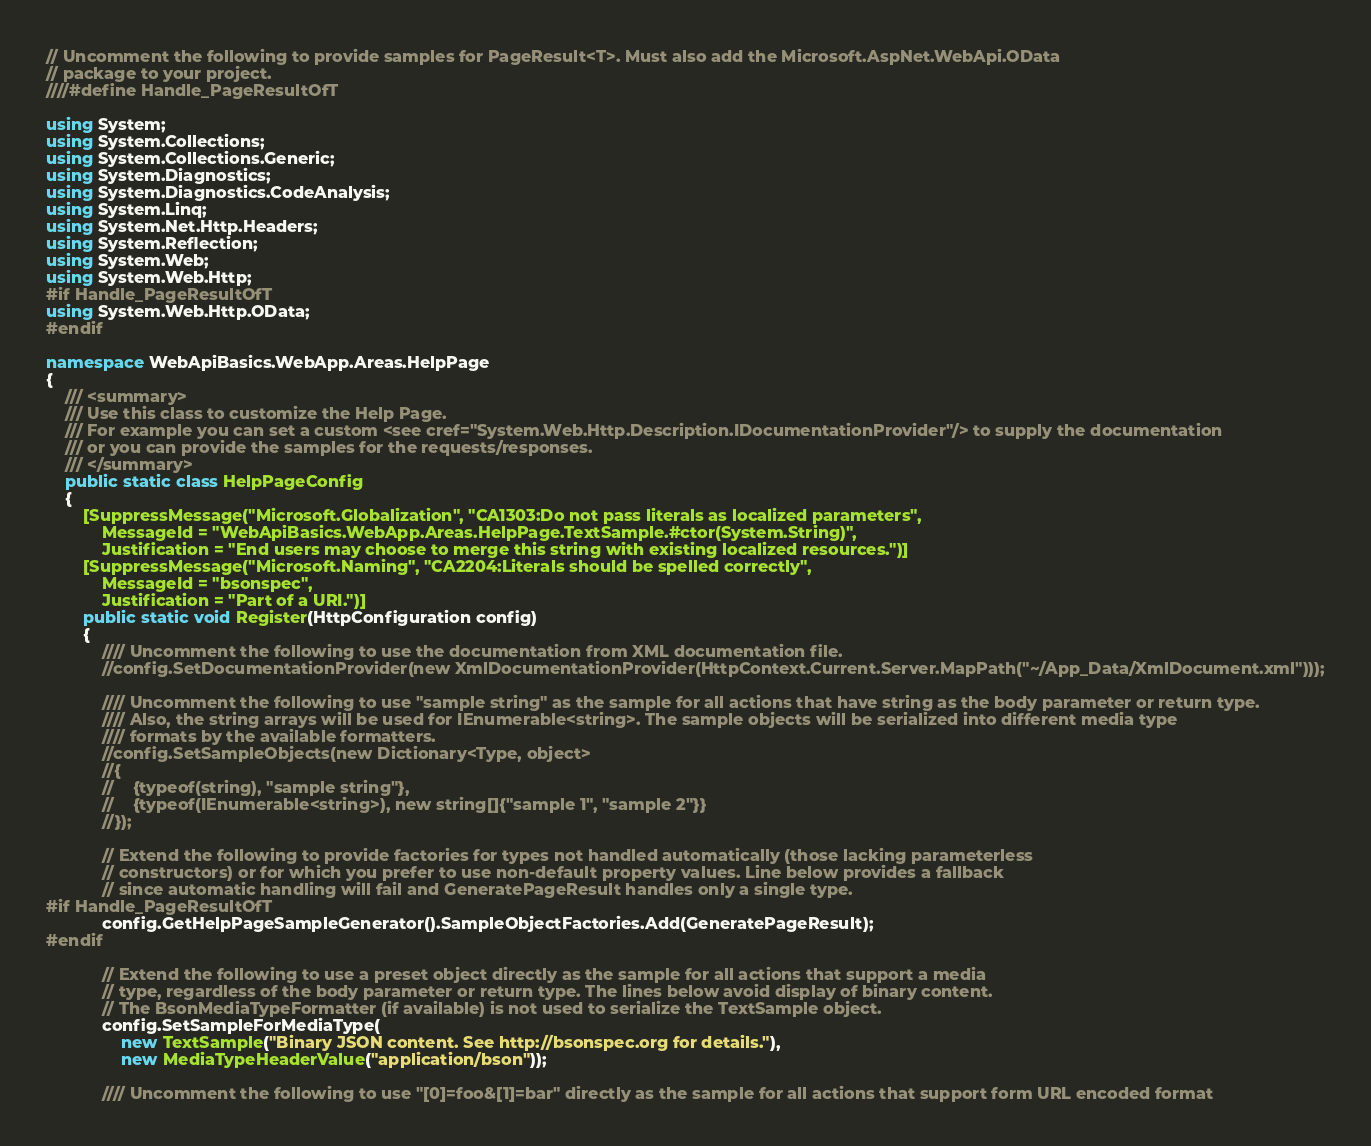Convert code to text. <code><loc_0><loc_0><loc_500><loc_500><_C#_>// Uncomment the following to provide samples for PageResult<T>. Must also add the Microsoft.AspNet.WebApi.OData
// package to your project.
////#define Handle_PageResultOfT

using System;
using System.Collections;
using System.Collections.Generic;
using System.Diagnostics;
using System.Diagnostics.CodeAnalysis;
using System.Linq;
using System.Net.Http.Headers;
using System.Reflection;
using System.Web;
using System.Web.Http;
#if Handle_PageResultOfT
using System.Web.Http.OData;
#endif

namespace WebApiBasics.WebApp.Areas.HelpPage
{
    /// <summary>
    /// Use this class to customize the Help Page.
    /// For example you can set a custom <see cref="System.Web.Http.Description.IDocumentationProvider"/> to supply the documentation
    /// or you can provide the samples for the requests/responses.
    /// </summary>
    public static class HelpPageConfig
    {
        [SuppressMessage("Microsoft.Globalization", "CA1303:Do not pass literals as localized parameters",
            MessageId = "WebApiBasics.WebApp.Areas.HelpPage.TextSample.#ctor(System.String)",
            Justification = "End users may choose to merge this string with existing localized resources.")]
        [SuppressMessage("Microsoft.Naming", "CA2204:Literals should be spelled correctly",
            MessageId = "bsonspec",
            Justification = "Part of a URI.")]
        public static void Register(HttpConfiguration config)
        {
            //// Uncomment the following to use the documentation from XML documentation file.
            //config.SetDocumentationProvider(new XmlDocumentationProvider(HttpContext.Current.Server.MapPath("~/App_Data/XmlDocument.xml")));

            //// Uncomment the following to use "sample string" as the sample for all actions that have string as the body parameter or return type.
            //// Also, the string arrays will be used for IEnumerable<string>. The sample objects will be serialized into different media type 
            //// formats by the available formatters.
            //config.SetSampleObjects(new Dictionary<Type, object>
            //{
            //    {typeof(string), "sample string"},
            //    {typeof(IEnumerable<string>), new string[]{"sample 1", "sample 2"}}
            //});

            // Extend the following to provide factories for types not handled automatically (those lacking parameterless
            // constructors) or for which you prefer to use non-default property values. Line below provides a fallback
            // since automatic handling will fail and GeneratePageResult handles only a single type.
#if Handle_PageResultOfT
            config.GetHelpPageSampleGenerator().SampleObjectFactories.Add(GeneratePageResult);
#endif

            // Extend the following to use a preset object directly as the sample for all actions that support a media
            // type, regardless of the body parameter or return type. The lines below avoid display of binary content.
            // The BsonMediaTypeFormatter (if available) is not used to serialize the TextSample object.
            config.SetSampleForMediaType(
                new TextSample("Binary JSON content. See http://bsonspec.org for details."),
                new MediaTypeHeaderValue("application/bson"));

            //// Uncomment the following to use "[0]=foo&[1]=bar" directly as the sample for all actions that support form URL encoded format</code> 